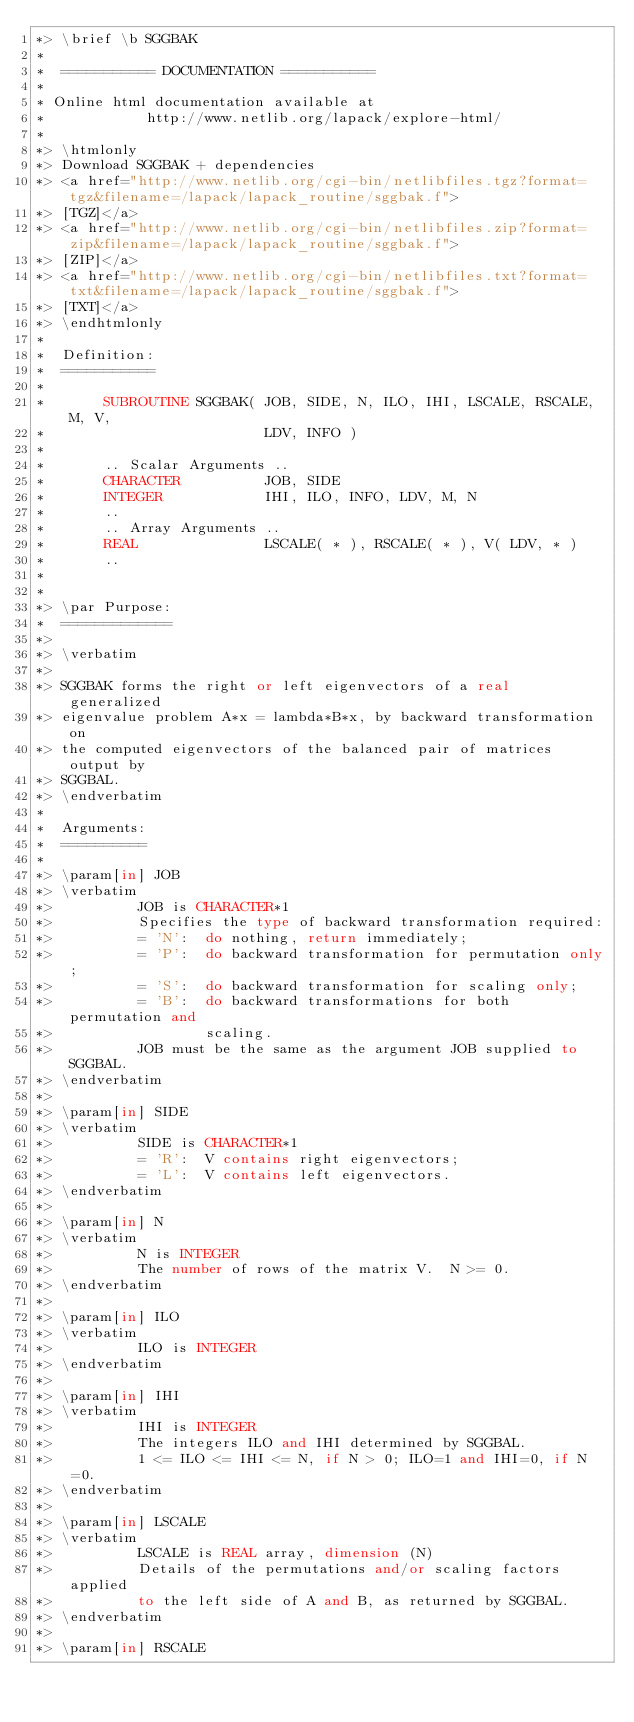Convert code to text. <code><loc_0><loc_0><loc_500><loc_500><_FORTRAN_>*> \brief \b SGGBAK
*
*  =========== DOCUMENTATION ===========
*
* Online html documentation available at
*            http://www.netlib.org/lapack/explore-html/
*
*> \htmlonly
*> Download SGGBAK + dependencies
*> <a href="http://www.netlib.org/cgi-bin/netlibfiles.tgz?format=tgz&filename=/lapack/lapack_routine/sggbak.f">
*> [TGZ]</a>
*> <a href="http://www.netlib.org/cgi-bin/netlibfiles.zip?format=zip&filename=/lapack/lapack_routine/sggbak.f">
*> [ZIP]</a>
*> <a href="http://www.netlib.org/cgi-bin/netlibfiles.txt?format=txt&filename=/lapack/lapack_routine/sggbak.f">
*> [TXT]</a>
*> \endhtmlonly
*
*  Definition:
*  ===========
*
*       SUBROUTINE SGGBAK( JOB, SIDE, N, ILO, IHI, LSCALE, RSCALE, M, V,
*                          LDV, INFO )
*
*       .. Scalar Arguments ..
*       CHARACTER          JOB, SIDE
*       INTEGER            IHI, ILO, INFO, LDV, M, N
*       ..
*       .. Array Arguments ..
*       REAL               LSCALE( * ), RSCALE( * ), V( LDV, * )
*       ..
*
*
*> \par Purpose:
*  =============
*>
*> \verbatim
*>
*> SGGBAK forms the right or left eigenvectors of a real generalized
*> eigenvalue problem A*x = lambda*B*x, by backward transformation on
*> the computed eigenvectors of the balanced pair of matrices output by
*> SGGBAL.
*> \endverbatim
*
*  Arguments:
*  ==========
*
*> \param[in] JOB
*> \verbatim
*>          JOB is CHARACTER*1
*>          Specifies the type of backward transformation required:
*>          = 'N':  do nothing, return immediately;
*>          = 'P':  do backward transformation for permutation only;
*>          = 'S':  do backward transformation for scaling only;
*>          = 'B':  do backward transformations for both permutation and
*>                  scaling.
*>          JOB must be the same as the argument JOB supplied to SGGBAL.
*> \endverbatim
*>
*> \param[in] SIDE
*> \verbatim
*>          SIDE is CHARACTER*1
*>          = 'R':  V contains right eigenvectors;
*>          = 'L':  V contains left eigenvectors.
*> \endverbatim
*>
*> \param[in] N
*> \verbatim
*>          N is INTEGER
*>          The number of rows of the matrix V.  N >= 0.
*> \endverbatim
*>
*> \param[in] ILO
*> \verbatim
*>          ILO is INTEGER
*> \endverbatim
*>
*> \param[in] IHI
*> \verbatim
*>          IHI is INTEGER
*>          The integers ILO and IHI determined by SGGBAL.
*>          1 <= ILO <= IHI <= N, if N > 0; ILO=1 and IHI=0, if N=0.
*> \endverbatim
*>
*> \param[in] LSCALE
*> \verbatim
*>          LSCALE is REAL array, dimension (N)
*>          Details of the permutations and/or scaling factors applied
*>          to the left side of A and B, as returned by SGGBAL.
*> \endverbatim
*>
*> \param[in] RSCALE</code> 